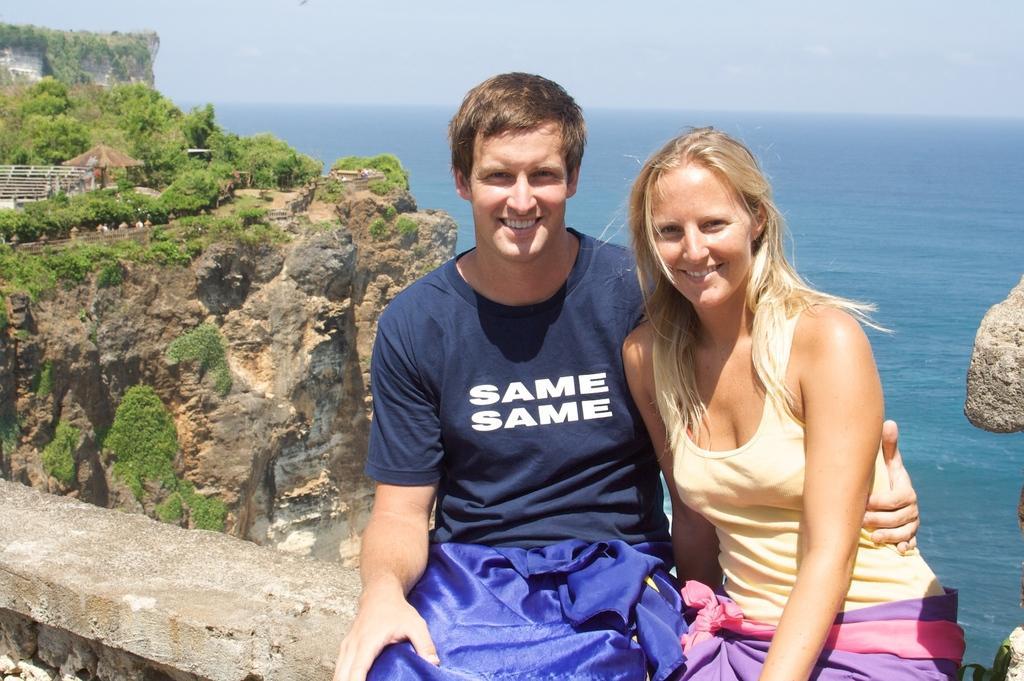Please provide a concise description of this image. In the image there is a man and a lady are sitting on the wall. Behind them there is water and also there is a hill with rocks, trees and huts. At the top of the image there is a sky. 